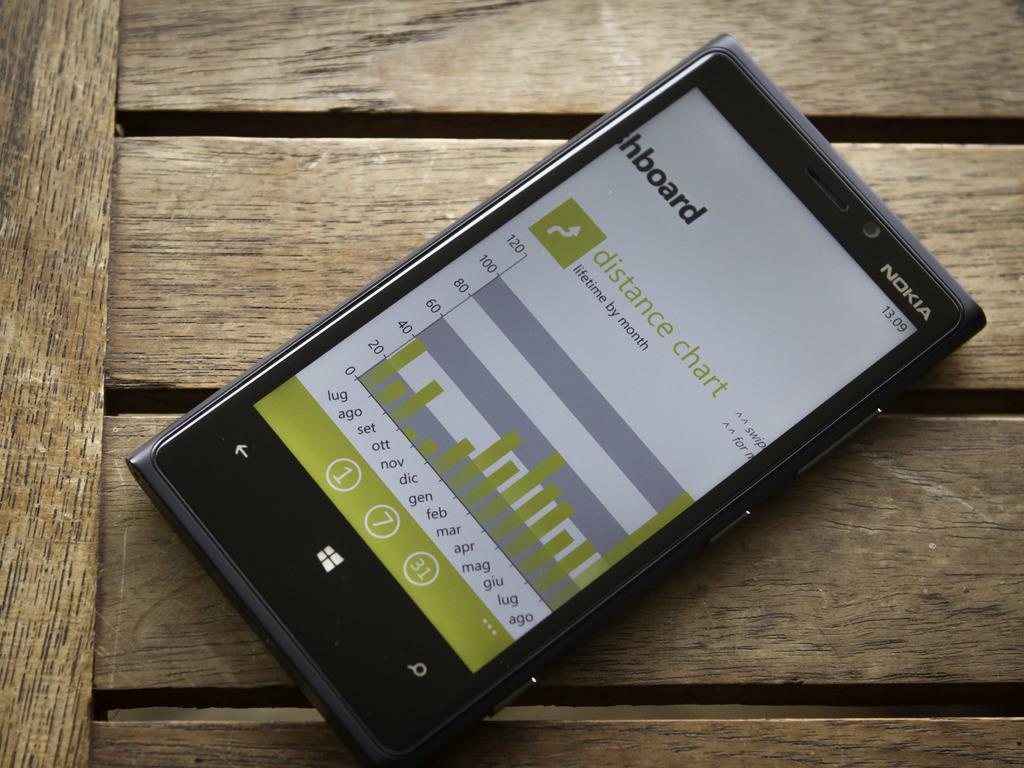<image>
Relay a brief, clear account of the picture shown. A Nokia brand phone displays a distance chart. 